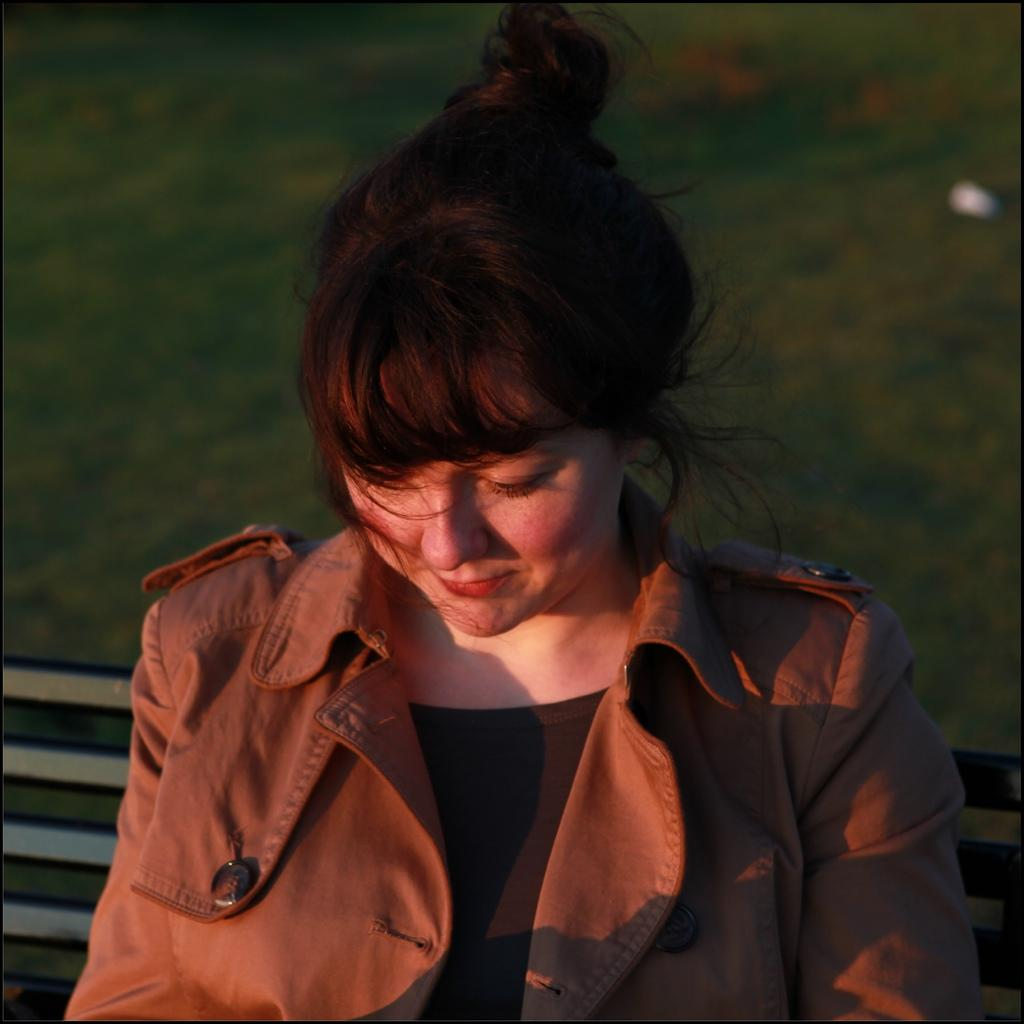Who is the main subject in the image? There is a lady in the image. What is the lady wearing? The lady is wearing a jacket. What is the lady doing in the image? The lady is sitting on a bench. What can be observed about the background of the image? The background appears to be green and blurred. What type of tree can be seen in the image? There is no tree present in the image. What is the purpose of the lady sitting on the bench in the image? The image does not provide information about the lady's purpose or intentions, so we cannot determine her purpose from the image alone. 